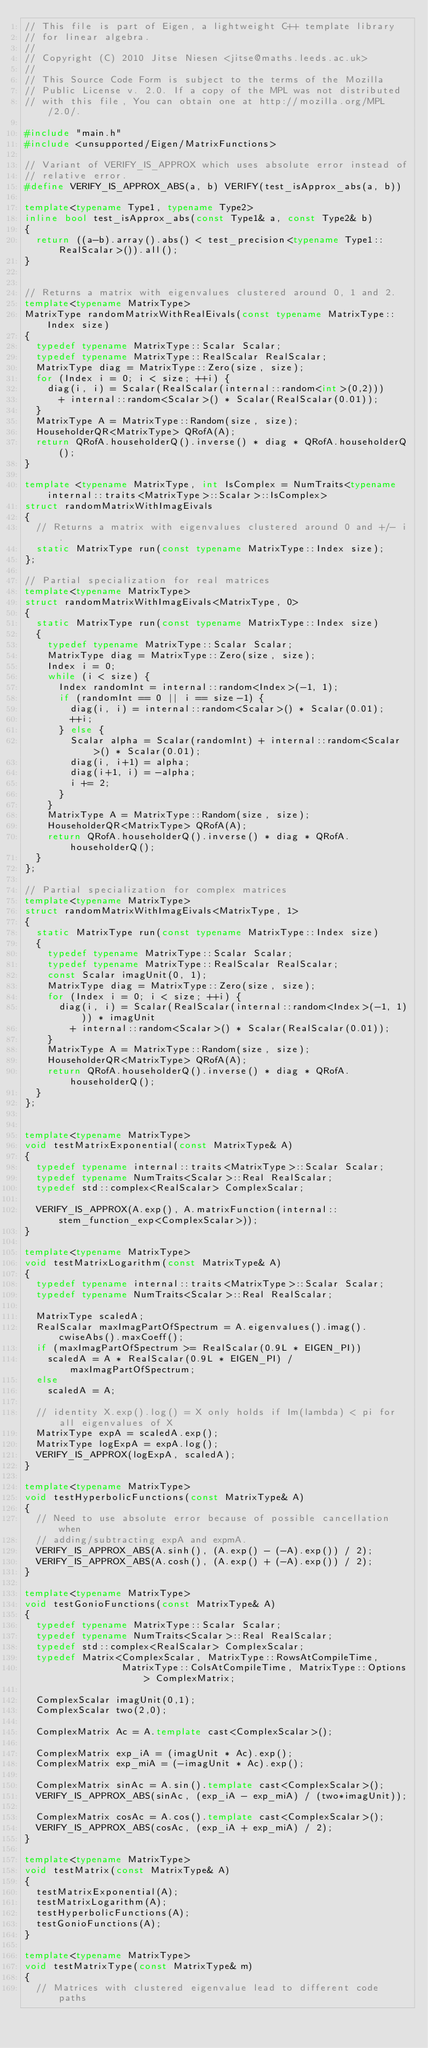Convert code to text. <code><loc_0><loc_0><loc_500><loc_500><_C++_>// This file is part of Eigen, a lightweight C++ template library
// for linear algebra.
//
// Copyright (C) 2010 Jitse Niesen <jitse@maths.leeds.ac.uk>
//
// This Source Code Form is subject to the terms of the Mozilla
// Public License v. 2.0. If a copy of the MPL was not distributed
// with this file, You can obtain one at http://mozilla.org/MPL/2.0/.

#include "main.h"
#include <unsupported/Eigen/MatrixFunctions>

// Variant of VERIFY_IS_APPROX which uses absolute error instead of
// relative error.
#define VERIFY_IS_APPROX_ABS(a, b) VERIFY(test_isApprox_abs(a, b))

template<typename Type1, typename Type2>
inline bool test_isApprox_abs(const Type1& a, const Type2& b)
{
  return ((a-b).array().abs() < test_precision<typename Type1::RealScalar>()).all();
}


// Returns a matrix with eigenvalues clustered around 0, 1 and 2.
template<typename MatrixType>
MatrixType randomMatrixWithRealEivals(const typename MatrixType::Index size)
{
  typedef typename MatrixType::Scalar Scalar;
  typedef typename MatrixType::RealScalar RealScalar;
  MatrixType diag = MatrixType::Zero(size, size);
  for (Index i = 0; i < size; ++i) {
    diag(i, i) = Scalar(RealScalar(internal::random<int>(0,2)))
      + internal::random<Scalar>() * Scalar(RealScalar(0.01));
  }
  MatrixType A = MatrixType::Random(size, size);
  HouseholderQR<MatrixType> QRofA(A);
  return QRofA.householderQ().inverse() * diag * QRofA.householderQ();
}

template <typename MatrixType, int IsComplex = NumTraits<typename internal::traits<MatrixType>::Scalar>::IsComplex>
struct randomMatrixWithImagEivals
{
  // Returns a matrix with eigenvalues clustered around 0 and +/- i.
  static MatrixType run(const typename MatrixType::Index size);
};

// Partial specialization for real matrices
template<typename MatrixType>
struct randomMatrixWithImagEivals<MatrixType, 0>
{
  static MatrixType run(const typename MatrixType::Index size)
  {
    typedef typename MatrixType::Scalar Scalar;
    MatrixType diag = MatrixType::Zero(size, size);
    Index i = 0;
    while (i < size) {
      Index randomInt = internal::random<Index>(-1, 1);
      if (randomInt == 0 || i == size-1) {
        diag(i, i) = internal::random<Scalar>() * Scalar(0.01);
        ++i;
      } else {
        Scalar alpha = Scalar(randomInt) + internal::random<Scalar>() * Scalar(0.01);
        diag(i, i+1) = alpha;
        diag(i+1, i) = -alpha;
        i += 2;
      }
    }
    MatrixType A = MatrixType::Random(size, size);
    HouseholderQR<MatrixType> QRofA(A);
    return QRofA.householderQ().inverse() * diag * QRofA.householderQ();
  }
};

// Partial specialization for complex matrices
template<typename MatrixType>
struct randomMatrixWithImagEivals<MatrixType, 1>
{
  static MatrixType run(const typename MatrixType::Index size)
  {
    typedef typename MatrixType::Scalar Scalar;
    typedef typename MatrixType::RealScalar RealScalar;
    const Scalar imagUnit(0, 1);
    MatrixType diag = MatrixType::Zero(size, size);
    for (Index i = 0; i < size; ++i) {
      diag(i, i) = Scalar(RealScalar(internal::random<Index>(-1, 1))) * imagUnit
        + internal::random<Scalar>() * Scalar(RealScalar(0.01));
    }
    MatrixType A = MatrixType::Random(size, size);
    HouseholderQR<MatrixType> QRofA(A);
    return QRofA.householderQ().inverse() * diag * QRofA.householderQ();
  }
};


template<typename MatrixType>
void testMatrixExponential(const MatrixType& A)
{
  typedef typename internal::traits<MatrixType>::Scalar Scalar;
  typedef typename NumTraits<Scalar>::Real RealScalar;
  typedef std::complex<RealScalar> ComplexScalar;

  VERIFY_IS_APPROX(A.exp(), A.matrixFunction(internal::stem_function_exp<ComplexScalar>));
}

template<typename MatrixType>
void testMatrixLogarithm(const MatrixType& A)
{
  typedef typename internal::traits<MatrixType>::Scalar Scalar;
  typedef typename NumTraits<Scalar>::Real RealScalar;

  MatrixType scaledA;
  RealScalar maxImagPartOfSpectrum = A.eigenvalues().imag().cwiseAbs().maxCoeff();
  if (maxImagPartOfSpectrum >= RealScalar(0.9L * EIGEN_PI))
    scaledA = A * RealScalar(0.9L * EIGEN_PI) / maxImagPartOfSpectrum;
  else
    scaledA = A;

  // identity X.exp().log() = X only holds if Im(lambda) < pi for all eigenvalues of X
  MatrixType expA = scaledA.exp();
  MatrixType logExpA = expA.log();
  VERIFY_IS_APPROX(logExpA, scaledA);
}

template<typename MatrixType>
void testHyperbolicFunctions(const MatrixType& A)
{
  // Need to use absolute error because of possible cancellation when
  // adding/subtracting expA and expmA.
  VERIFY_IS_APPROX_ABS(A.sinh(), (A.exp() - (-A).exp()) / 2);
  VERIFY_IS_APPROX_ABS(A.cosh(), (A.exp() + (-A).exp()) / 2);
}

template<typename MatrixType>
void testGonioFunctions(const MatrixType& A)
{
  typedef typename MatrixType::Scalar Scalar;
  typedef typename NumTraits<Scalar>::Real RealScalar;
  typedef std::complex<RealScalar> ComplexScalar;
  typedef Matrix<ComplexScalar, MatrixType::RowsAtCompileTime, 
                 MatrixType::ColsAtCompileTime, MatrixType::Options> ComplexMatrix;

  ComplexScalar imagUnit(0,1);
  ComplexScalar two(2,0);

  ComplexMatrix Ac = A.template cast<ComplexScalar>();
  
  ComplexMatrix exp_iA = (imagUnit * Ac).exp();
  ComplexMatrix exp_miA = (-imagUnit * Ac).exp();
  
  ComplexMatrix sinAc = A.sin().template cast<ComplexScalar>();
  VERIFY_IS_APPROX_ABS(sinAc, (exp_iA - exp_miA) / (two*imagUnit));
  
  ComplexMatrix cosAc = A.cos().template cast<ComplexScalar>();
  VERIFY_IS_APPROX_ABS(cosAc, (exp_iA + exp_miA) / 2);
}

template<typename MatrixType>
void testMatrix(const MatrixType& A)
{
  testMatrixExponential(A);
  testMatrixLogarithm(A);
  testHyperbolicFunctions(A);
  testGonioFunctions(A);
}

template<typename MatrixType>
void testMatrixType(const MatrixType& m)
{
  // Matrices with clustered eigenvalue lead to different code paths</code> 